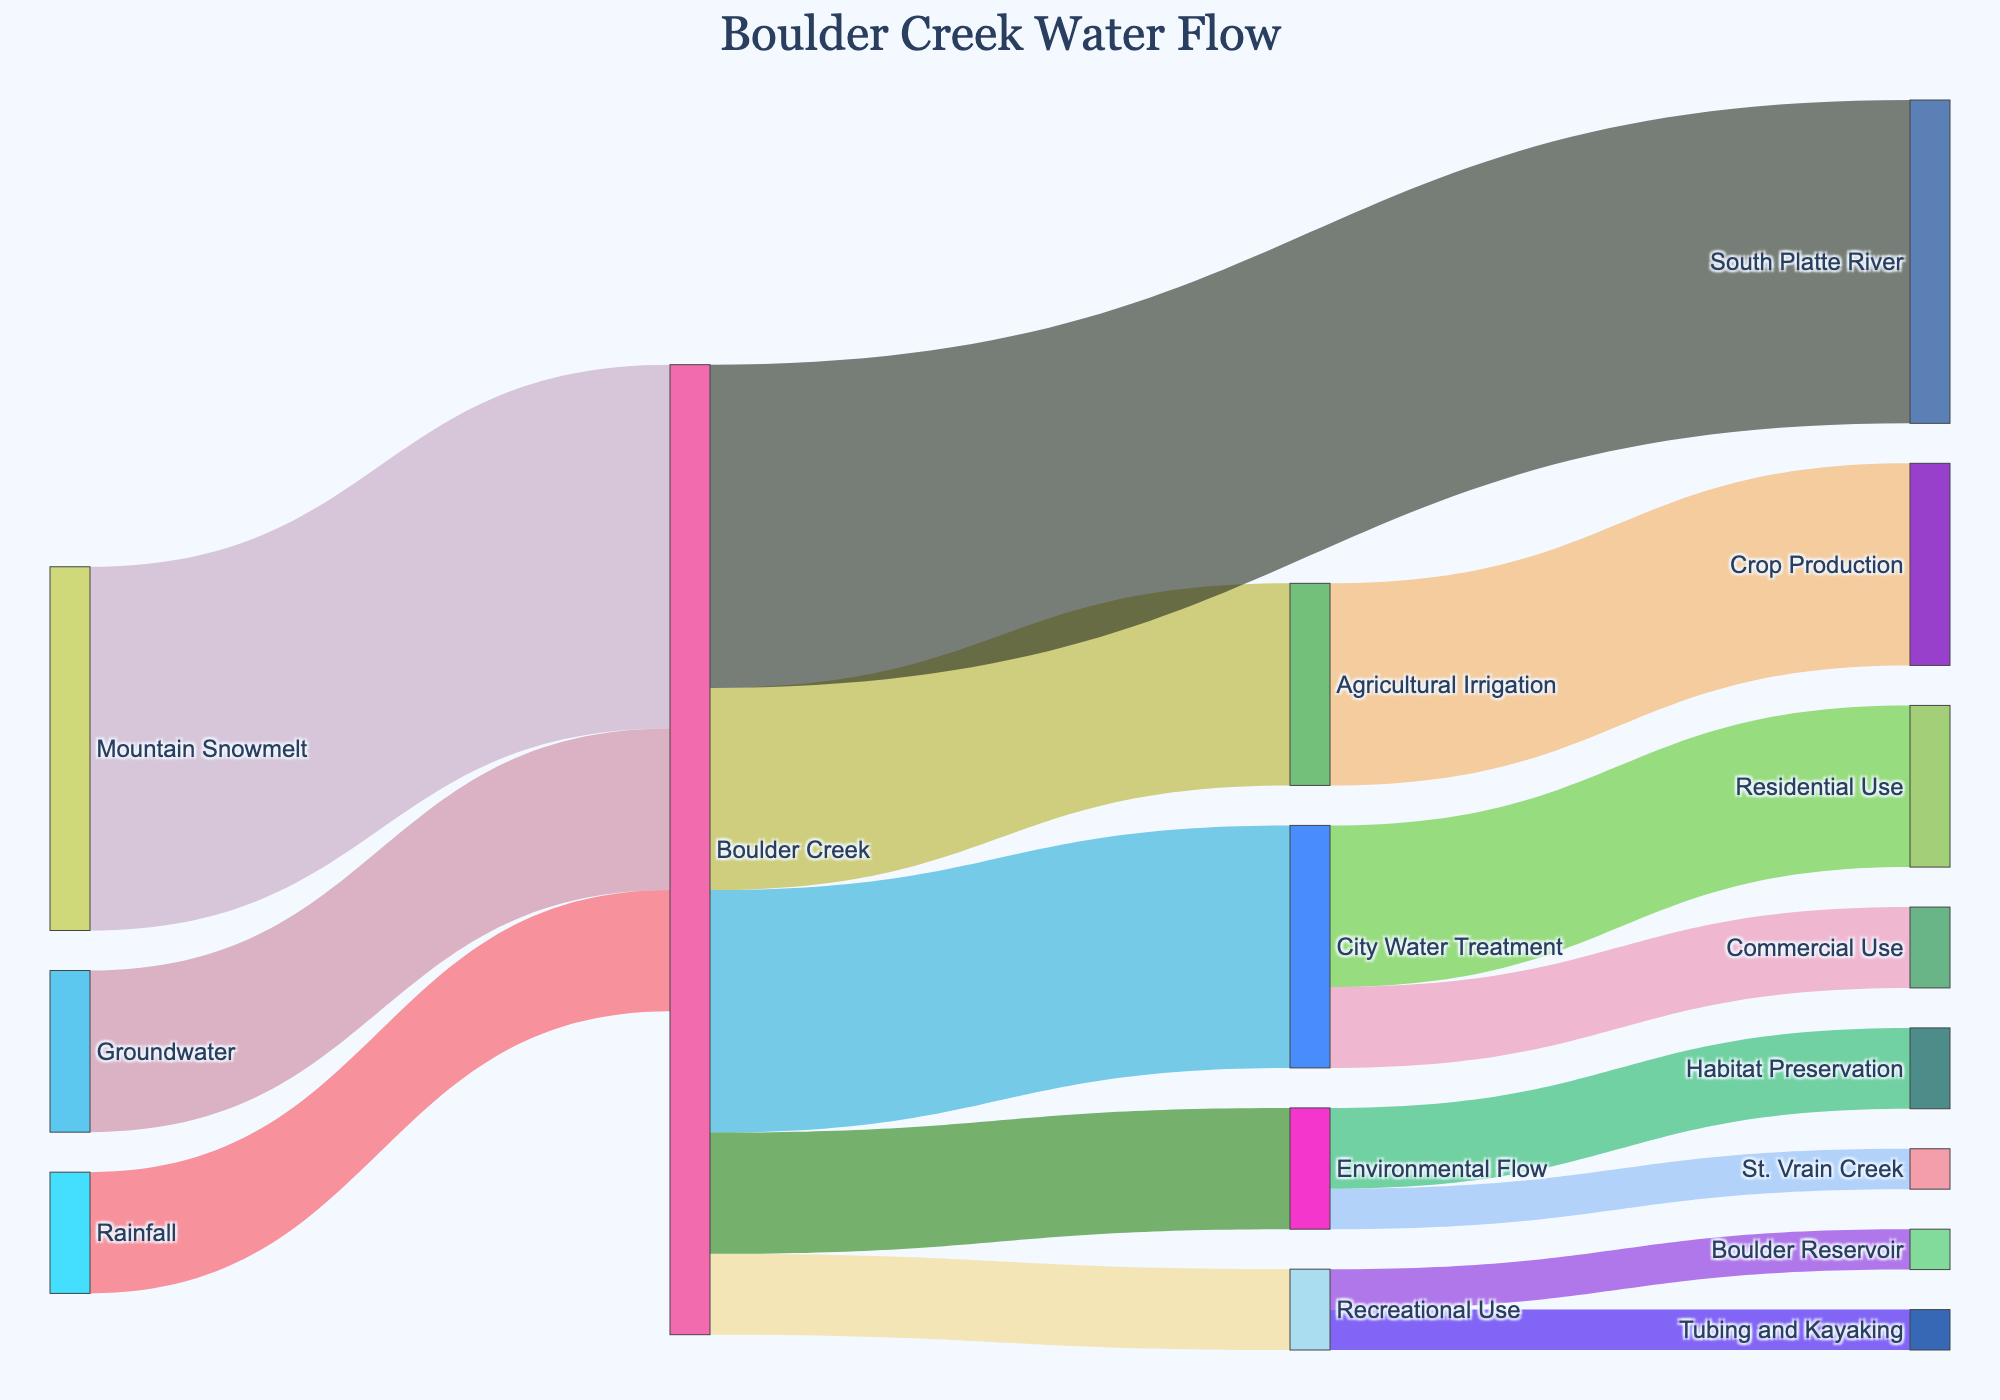What is the primary source of water in Boulder Creek? By examining the thickness of the flows leading to Boulder Creek, the largest flow is from Mountain Snowmelt with a value of 45 units compared to other sources.
Answer: Mountain Snowmelt How much water is used for Agricultural Irrigation from Boulder Creek? Observing the flows from Boulder Creek to its various targets, the flow to Agricultural Irrigation is 25 units.
Answer: 25 units What are the downstream destinations of Boulder Creek water? From the diagram, the flows going out of Boulder Creek lead to City Water Treatment, Agricultural Irrigation, Recreational Use, Environmental Flow, and the South Platte River.
Answer: City Water Treatment, Agricultural Irrigation, Recreational Use, Environmental Flow, South Platte River What is the combined water contribution from Groundwater and Rainfall to Boulder Creek? The separate contributions are Groundwater at 20 units and Rainfall at 15 units. Adding these gives 20 + 15 = 35 units.
Answer: 35 units Which usage from the City Water Treatment has the greater flow, Residential Use or Commercial Use? Looking at the flows from City Water Treatment, Residential Use has a value of 20 units, and Commercial Use has 10 units. Residential Use has the greater flow.
Answer: Residential Use How much total water is initially added to Boulder Creek from all sources? Adding up all the initial sources' contributions to Boulder Creek: Mountain Snowmelt (45) + Groundwater (20) + Rainfall (15) equals 80 units.
Answer: 80 units How much water ends up in the South Platte River from Boulder Creek? Observing the flow from Boulder Creek to the South Platte River, the amount is 40 units.
Answer: 40 units Which is larger: the water used for Habitat Preservation or the water flowing into St. Vrain Creek from Environmental Flow? Habitat Preservation receives 10 units, while St. Vrain Creek receives 5 units. Habitat Preservation is larger.
Answer: Habitat Preservation What is the total recreational water use from Boulder Creek? Adding the flows to Recreational Use, i.e., Boulder Reservoir (5) and Tubing and Kayaking (5), gives a total of 10 units.
Answer: 10 units Does more water flow from City Water Treatment to Residential Use or from Boulder Creek to Agricultural Irrigation? Comparing the two flows, City Water Treatment to Residential Use is 20 units, and Boulder Creek to Agricultural Irrigation is 25 units. Agricultural Irrigation has more.
Answer: Agricultural Irrigation 